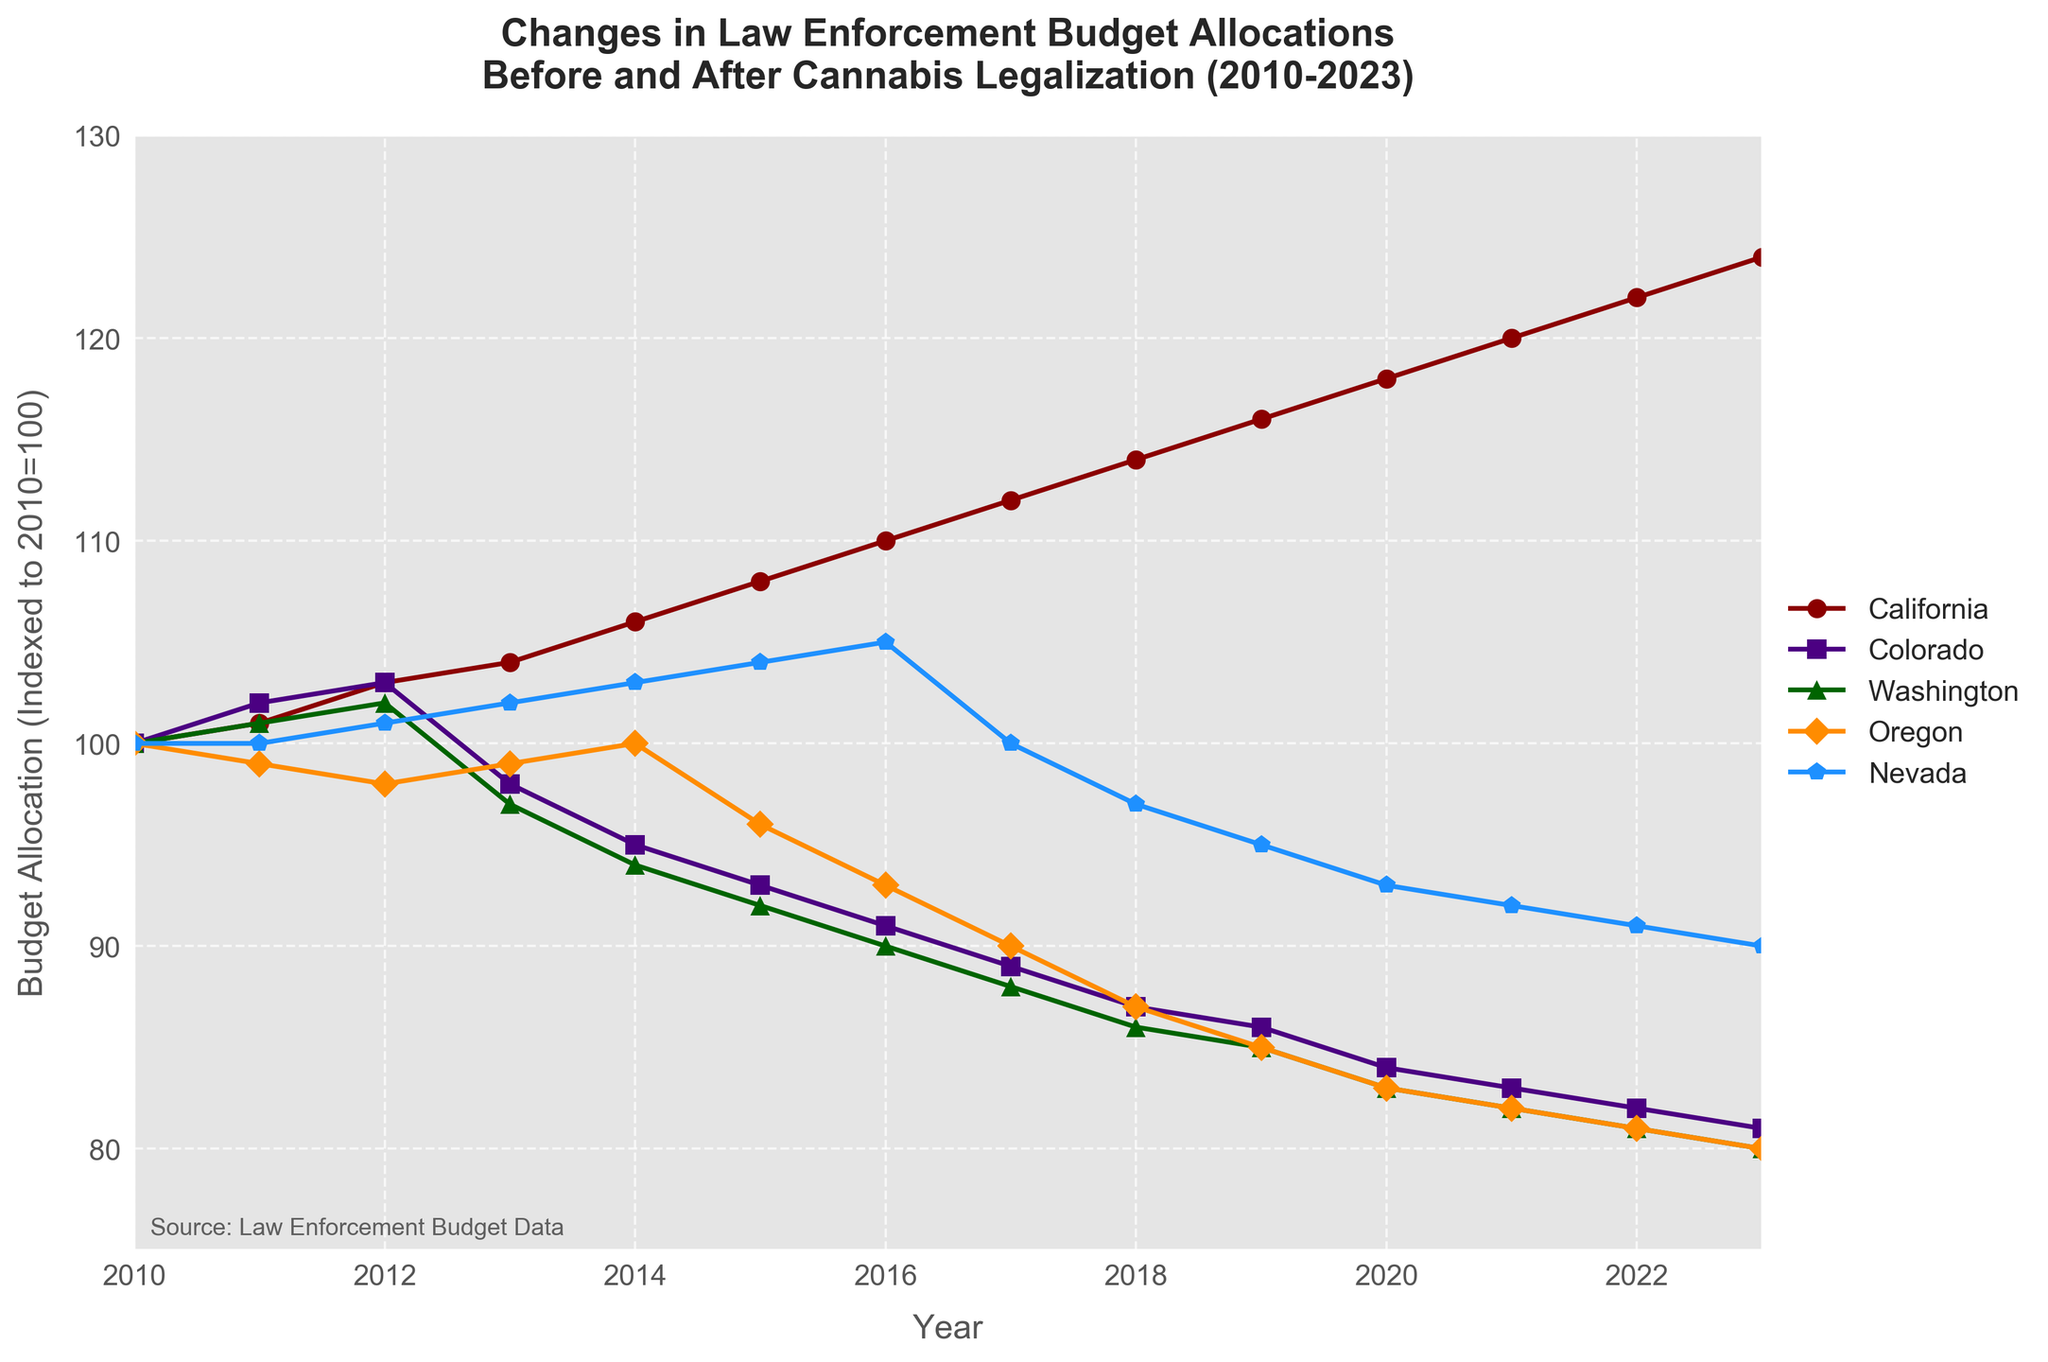How did the budget allocation for California change from 2010 to 2023? First, identify California's budget allocation in 2010, which is 100. Then identify it in 2023, which is 124. The change is 124 - 100 = 24.
Answer: 24 Which state showed the biggest decrease in budget allocation from 2010 to 2023? Compare the budget allocations for each state in 2010 and 2023. For California (100 to 124), Colorado (100 to 81), Washington (100 to 80), Oregon (100 to 80), and Nevada (100 to 90). The biggest decrease is for Washington and Oregon, from 100 to 80.
Answer: Washington or Oregon Between 2013 and 2017, which state experienced the largest percentage decrease in budget allocation? Calculate the percentage decrease for each state between 2013 and 2017. For California (.112-104)/104 ≈ 0.0769 (7.69%), Colorado (98-89)/98 = 0.0918 (9.18%), Washington (97-88)/97 ≈ 0.0928 (9.28%), Oregon (99-90)/99 ≈ 0.0909 (9.09%), Nevada (102-100)/102 ≈ 0.0196 (1.96%). Washington experienced the largest percentage decrease.
Answer: Washington What is the average budget allocation for Nevada across all the years? Sum all the budget allocations for Nevada and divide by the number of years. (100 + 100 + 101 + 102 + 103 + 104 + 105 + 100 + 97 + 95 + 93 + 92 + 91 + 90)/14 = 94.07.
Answer: 94.07 Did the budget allocation for Oregon ever increase after cannabis legalization in 2015? Examine Oregon’s budget allocation from 2015 onwards: 96 (2015), 93 (2016), 90 (2017), 87 (2018), 85 (2019), 83 (2020), 82 (2021), 81 (2022), and 80 (2023). It is a consistent decrease.
Answer: No By how much did Colorado's budget allocation decrease in percentage terms from 2010 to 2023? Determine Colorado's budget in 2010 and 2023. Percentage change = [(81 - 100) / 100] x 100 = -19%.
Answer: 19 Which state had a relatively stable budget allocation compared to others? Compare fluctuations in the budget allocations from 2010 to 2023. California (24 points change), Colorado (19 points), Washington (20 points), Oregon (20 points), Nevada (10 points). Nevada has the most stable allocation with the smallest change.
Answer: Nevada How did the average budget allocation change for Colorado from 2010 to 2017 compared to 2018 to 2023? Compute the average for 2010-2017 and 2018-2023. For 2010-2017: (100 + 102 + 103 + 98 + 95 + 93 + 91 + 89)/8 = 96.375. For 2018-2023: (87 + 86 + 84 + 83 + 82 + 81)/6 = 83.83. The difference is 96.375 - 83.83 ≈ 12.54.
Answer: Decreased by 12.54 Which year did California surpass a budget allocation of 110 for the first time? Identify the first year where California's budget allocation surpasses 110. For California, 110 was surpassed in 2016.
Answer: 2016 